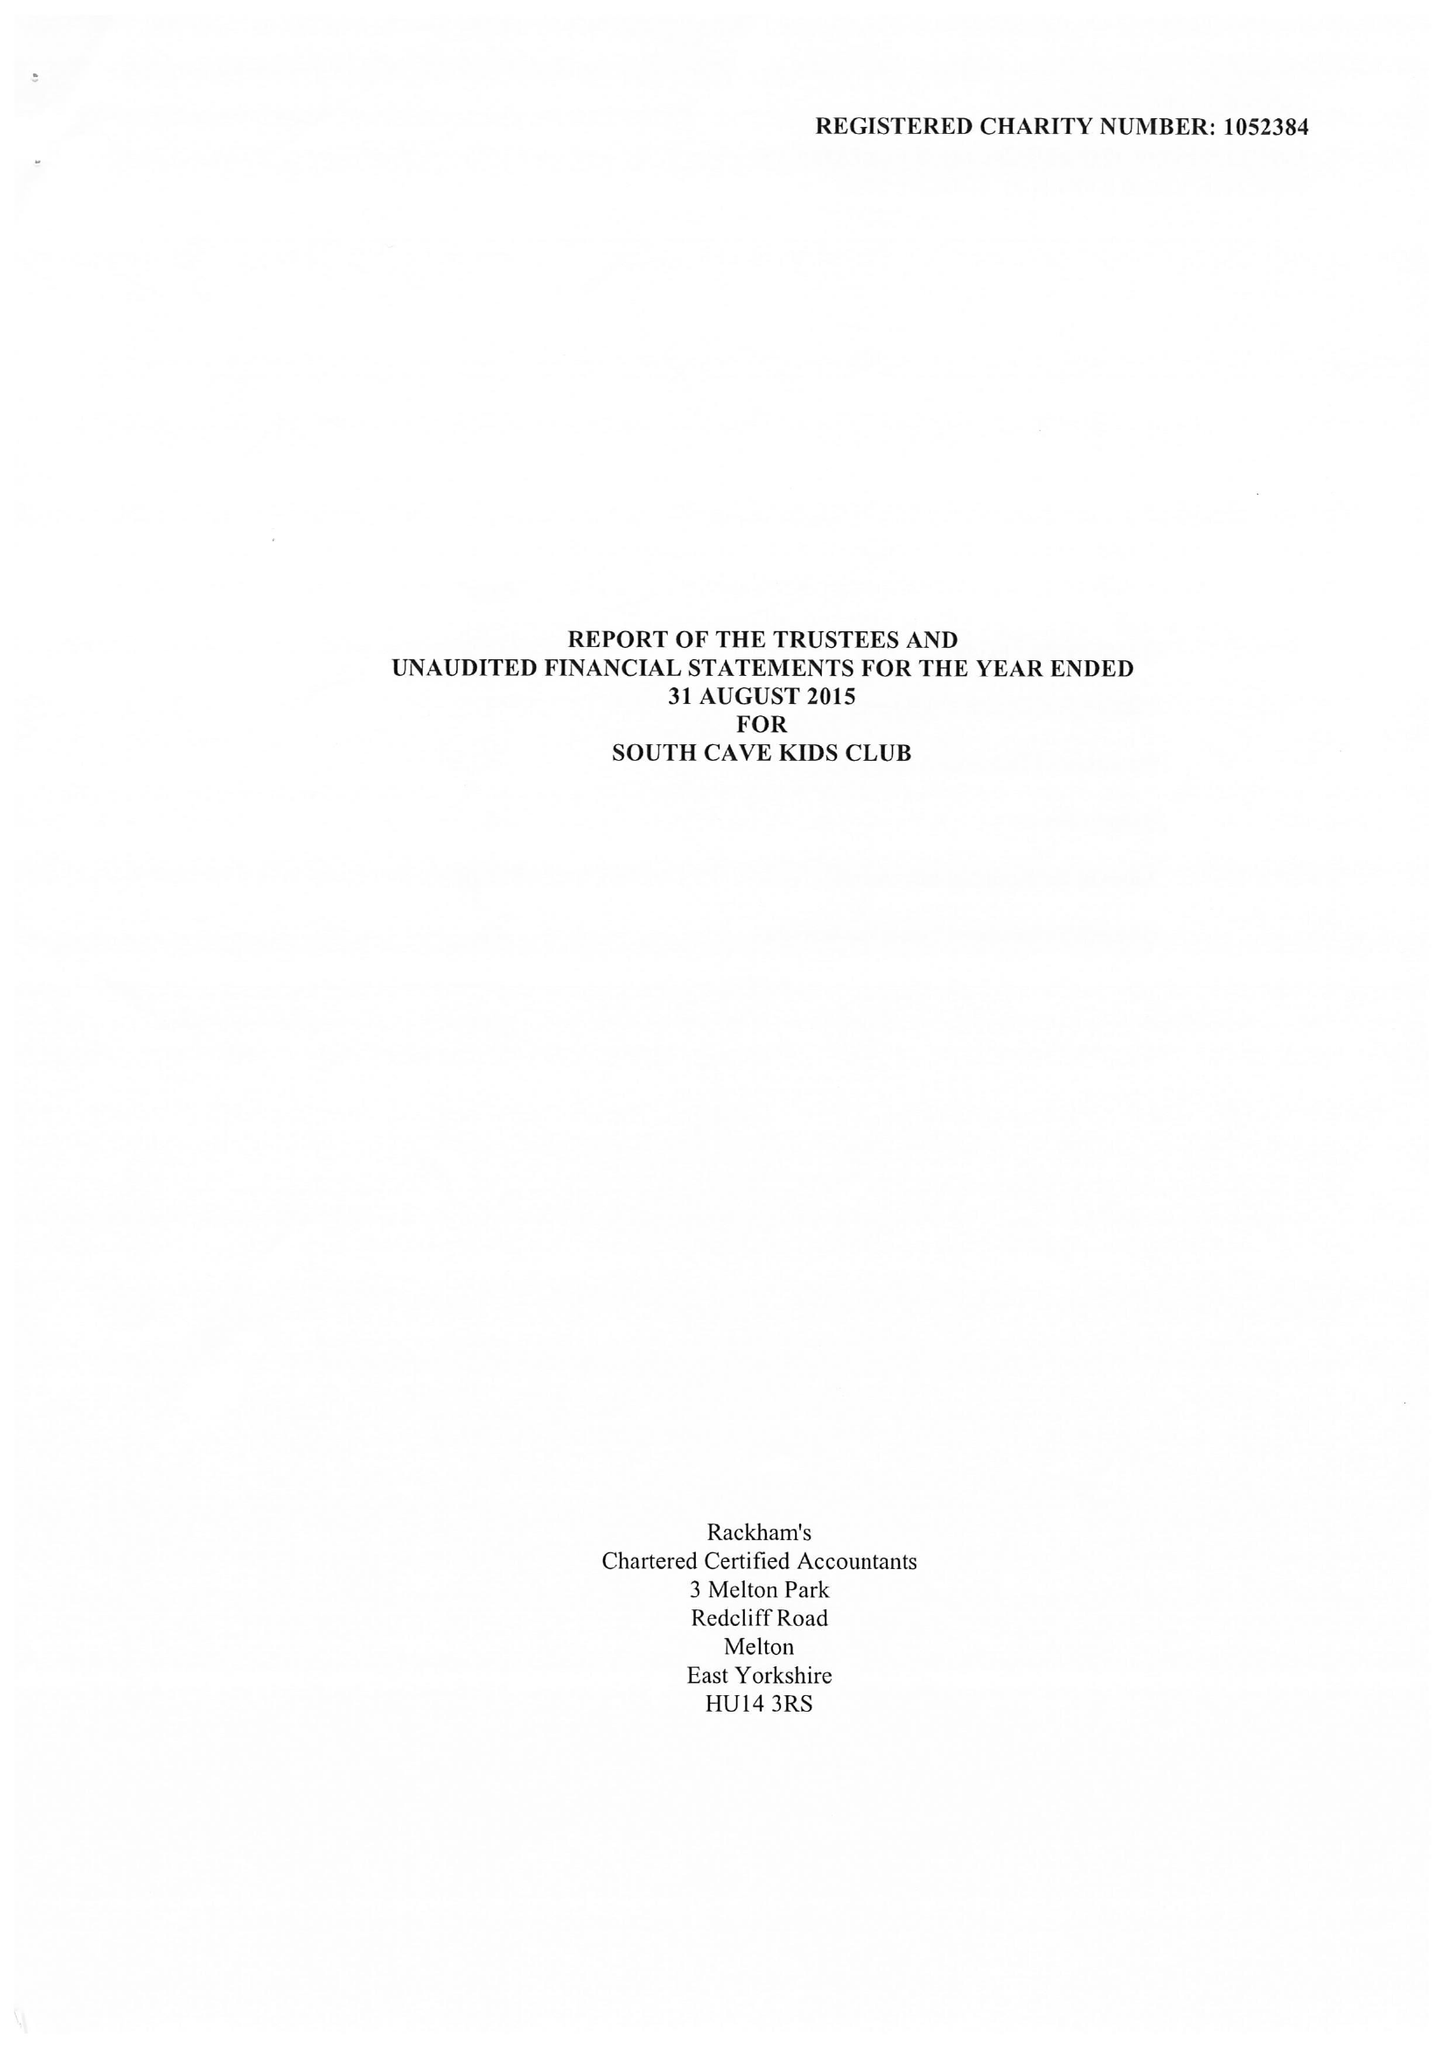What is the value for the report_date?
Answer the question using a single word or phrase. 2015-08-31 